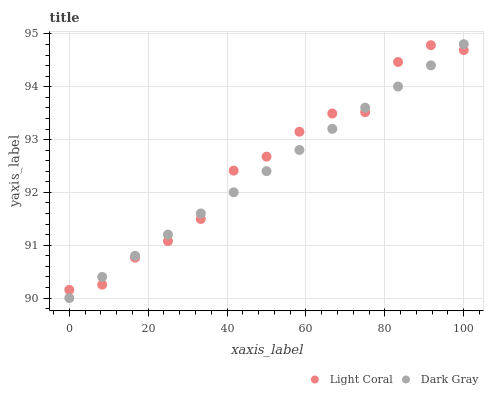Does Dark Gray have the minimum area under the curve?
Answer yes or no. Yes. Does Light Coral have the maximum area under the curve?
Answer yes or no. Yes. Does Dark Gray have the maximum area under the curve?
Answer yes or no. No. Is Dark Gray the smoothest?
Answer yes or no. Yes. Is Light Coral the roughest?
Answer yes or no. Yes. Is Dark Gray the roughest?
Answer yes or no. No. Does Dark Gray have the lowest value?
Answer yes or no. Yes. Does Dark Gray have the highest value?
Answer yes or no. Yes. Does Light Coral intersect Dark Gray?
Answer yes or no. Yes. Is Light Coral less than Dark Gray?
Answer yes or no. No. Is Light Coral greater than Dark Gray?
Answer yes or no. No. 